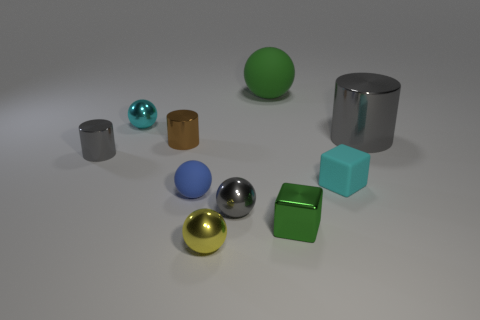How many tiny metal objects are both in front of the cyan metal sphere and on the left side of the yellow shiny object?
Make the answer very short. 2. There is a green thing behind the tiny gray metallic cylinder; what material is it?
Your answer should be compact. Rubber. The block that is the same material as the small yellow sphere is what size?
Your answer should be very brief. Small. There is a gray object left of the brown shiny object; is its size the same as the metallic ball that is on the left side of the yellow thing?
Provide a short and direct response. Yes. What material is the other cyan block that is the same size as the metal block?
Ensure brevity in your answer.  Rubber. There is a small thing that is right of the big green matte sphere and in front of the cyan rubber cube; what material is it?
Your response must be concise. Metal. Are any metallic things visible?
Provide a short and direct response. Yes. Do the metallic cube and the small rubber object left of the yellow ball have the same color?
Offer a very short reply. No. What is the material of the big thing that is the same color as the small metal block?
Your answer should be very brief. Rubber. Are there any other things that are the same shape as the yellow metallic thing?
Keep it short and to the point. Yes. 